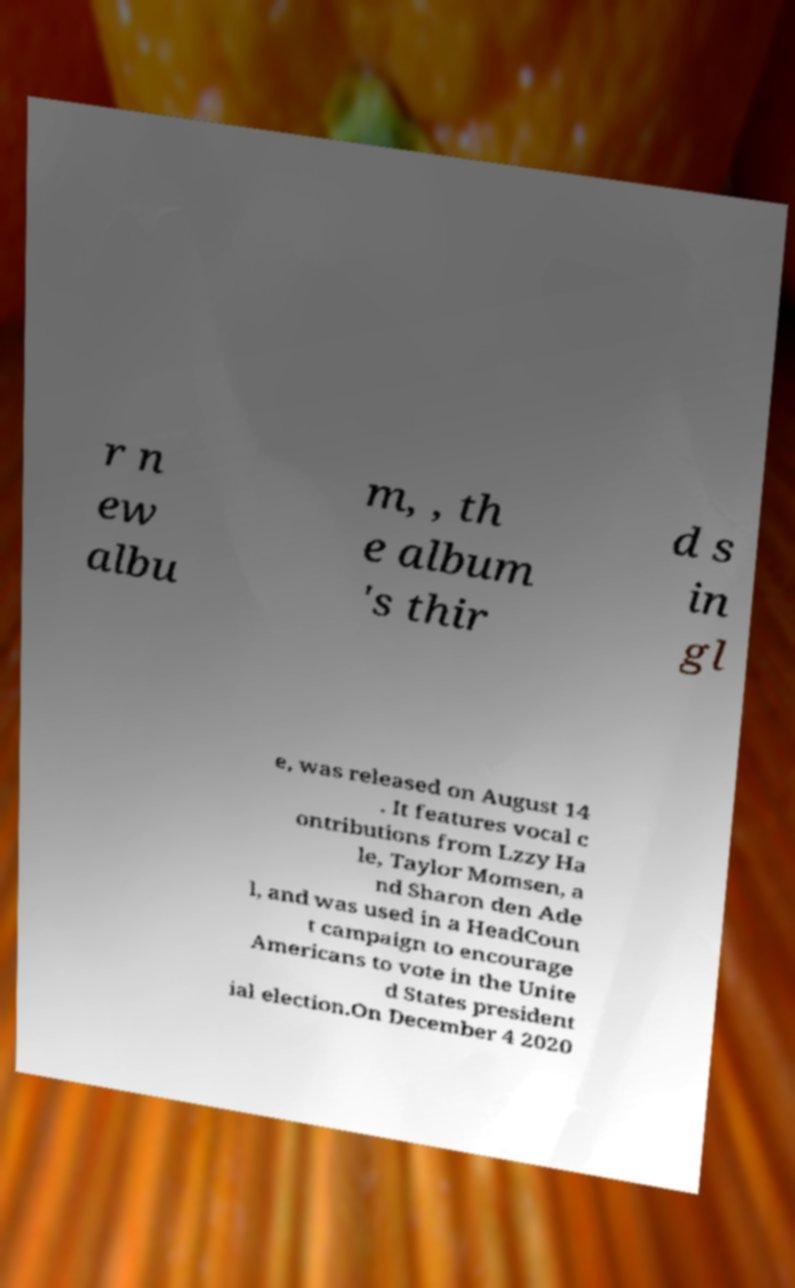Please read and relay the text visible in this image. What does it say? r n ew albu m, , th e album 's thir d s in gl e, was released on August 14 . It features vocal c ontributions from Lzzy Ha le, Taylor Momsen, a nd Sharon den Ade l, and was used in a HeadCoun t campaign to encourage Americans to vote in the Unite d States president ial election.On December 4 2020 